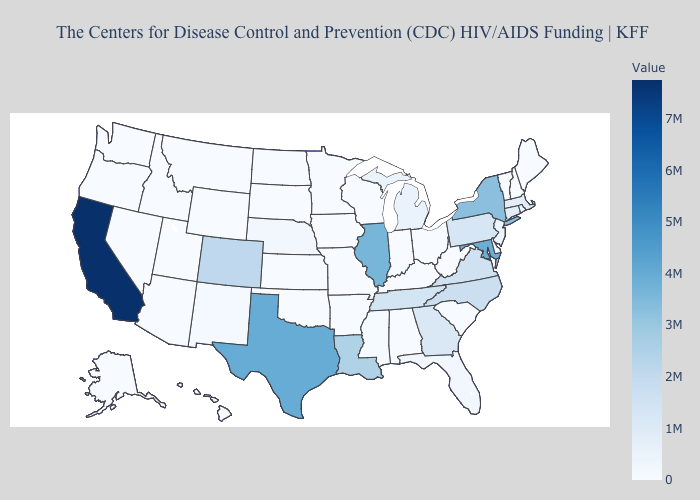Which states hav the highest value in the South?
Keep it brief. Texas. Among the states that border Tennessee , does North Carolina have the highest value?
Concise answer only. Yes. Does South Dakota have the lowest value in the USA?
Answer briefly. Yes. Is the legend a continuous bar?
Give a very brief answer. Yes. Does Ohio have the lowest value in the MidWest?
Write a very short answer. Yes. 